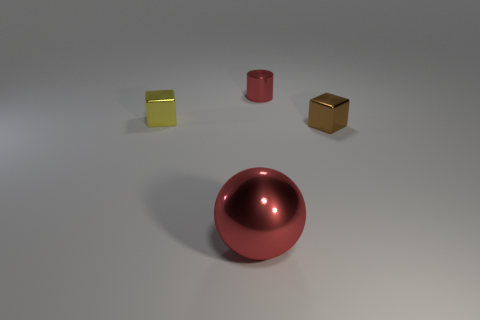Is there anything else that is the same size as the metal sphere?
Your response must be concise. No. Are there any large spheres of the same color as the shiny cylinder?
Give a very brief answer. Yes. How many things are yellow blocks behind the large metallic object or blocks left of the metal ball?
Your answer should be compact. 1. Is the tiny shiny cylinder the same color as the ball?
Offer a very short reply. Yes. There is a small cylinder that is the same color as the shiny ball; what is its material?
Provide a succinct answer. Metal. Is the number of red metal balls that are to the left of the red sphere less than the number of tiny metal objects on the right side of the small brown shiny cube?
Offer a very short reply. No. Is the small red cylinder made of the same material as the tiny brown block?
Give a very brief answer. Yes. What size is the thing that is both behind the tiny brown cube and left of the metallic cylinder?
Offer a terse response. Small. What shape is the brown thing that is the same size as the yellow shiny cube?
Ensure brevity in your answer.  Cube. What material is the block that is in front of the tiny block that is to the left of the block that is right of the big red metallic thing?
Your answer should be compact. Metal. 